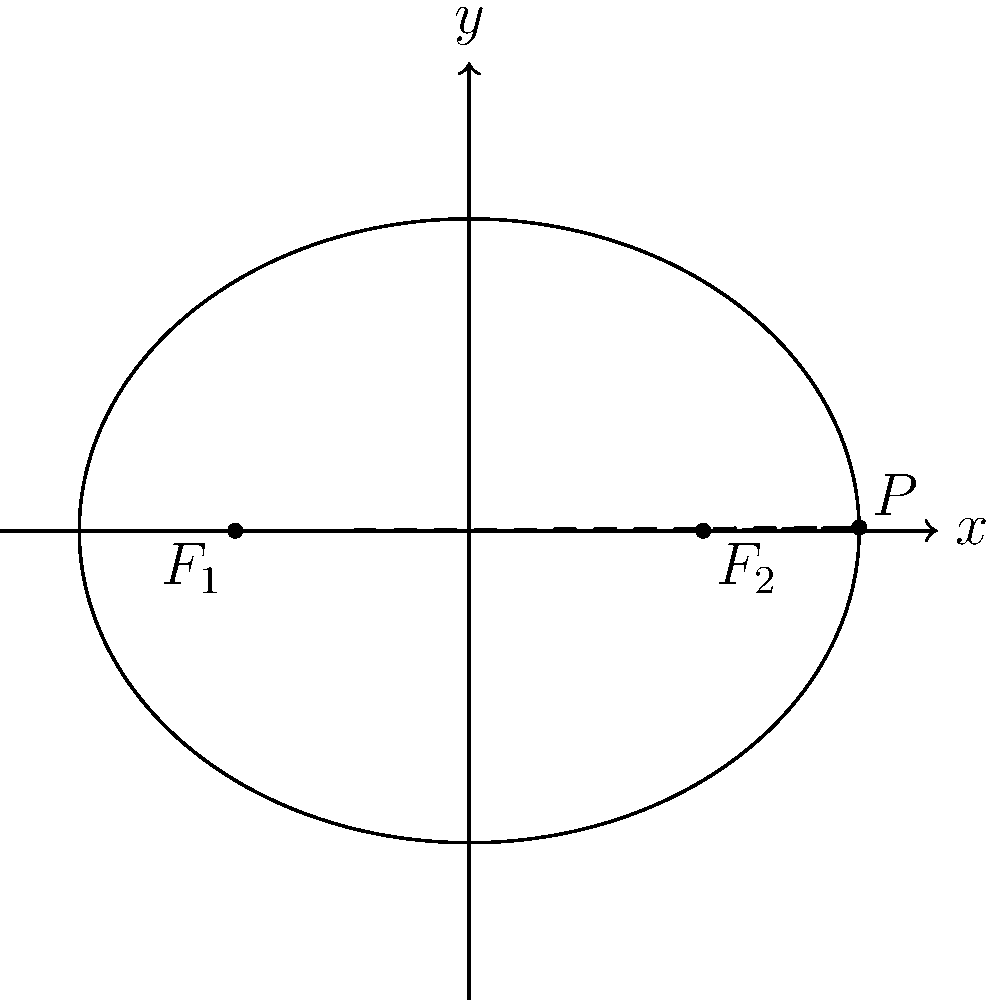In designing an optimal prosthetic socket, we model the cross-section as an ellipse. The ellipse has foci at $F_1(-1.5, 0)$ and $F_2(1.5, 0)$, and a semi-major axis of length 2.5 units. Calculate the eccentricity of this ellipse to determine the socket's curvature. How would this affect the fit and comfort of the prosthetic? Let's approach this step-by-step:

1) The eccentricity of an ellipse is given by the formula:
   $$e = \frac{c}{a}$$
   where $c$ is the distance from the center to a focus, and $a$ is the length of the semi-major axis.

2) We're given that $a = 2.5$ units.

3) To find $c$, we can use the distance between the foci:
   $2c = |F_1F_2| = |-1.5 - 1.5| = 3$
   Therefore, $c = 1.5$ units.

4) Now we can calculate the eccentricity:
   $$e = \frac{c}{a} = \frac{1.5}{2.5} = 0.6$$

5) The eccentricity of an ellipse is always between 0 and 1. A value of 0.6 indicates a moderately eccentric ellipse.

6) In terms of the prosthetic socket:
   - This eccentricity suggests a socket that's neither perfectly circular (which would have $e = 0$) nor extremely elongated.
   - It provides a balance between conforming to the limb's natural shape and allowing for some adjustability.
   - A moderate eccentricity like this can offer good stability while still allowing for comfort and movement.
   - However, the optimal eccentricity would depend on the specific user's limb shape and activity level.
Answer: Eccentricity = 0.6; balanced fit, moderate conformity to limb shape 